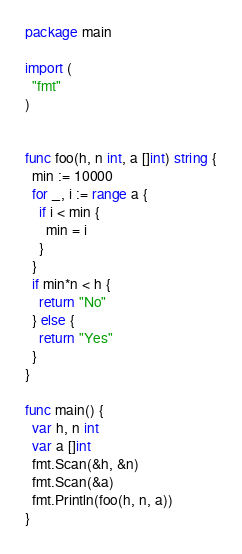<code> <loc_0><loc_0><loc_500><loc_500><_Go_>package main

import (
  "fmt"
)


func foo(h, n int, a []int) string {
  min := 10000
  for _, i := range a {
    if i < min {
      min = i
    }
  }
  if min*n < h {
    return "No"
  } else {
    return "Yes"
  }
}

func main() {
  var h, n int
  var a []int
  fmt.Scan(&h, &n)
  fmt.Scan(&a)
  fmt.Println(foo(h, n, a))
}
</code> 